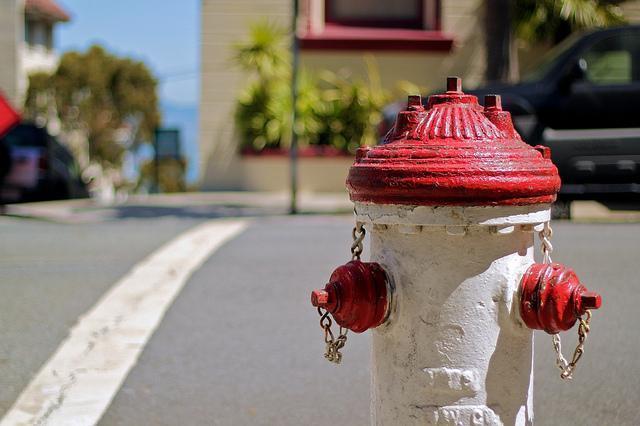What does the line near the hydrant signify?
Indicate the correct response by choosing from the four available options to answer the question.
Options: Hopscotch boundary, road intersection, turn here, handicap parking. Road intersection. 